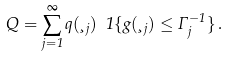Convert formula to latex. <formula><loc_0><loc_0><loc_500><loc_500>Q = \sum _ { j = 1 } ^ { \infty } q ( \xi _ { j } ) \ 1 \{ g ( \xi _ { j } ) \leq \Gamma _ { j } ^ { - 1 } \} \, .</formula> 